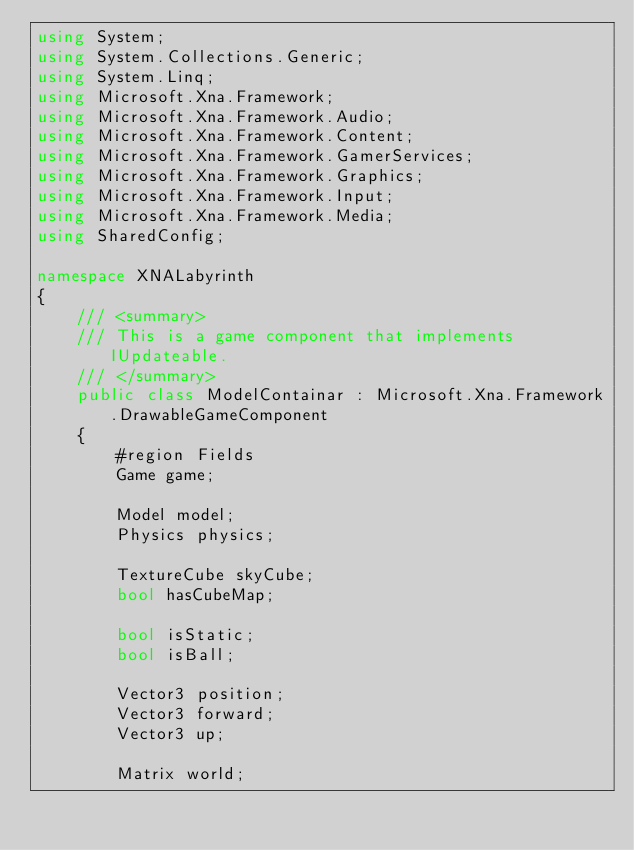<code> <loc_0><loc_0><loc_500><loc_500><_C#_>using System;
using System.Collections.Generic;
using System.Linq;
using Microsoft.Xna.Framework;
using Microsoft.Xna.Framework.Audio;
using Microsoft.Xna.Framework.Content;
using Microsoft.Xna.Framework.GamerServices;
using Microsoft.Xna.Framework.Graphics;
using Microsoft.Xna.Framework.Input;
using Microsoft.Xna.Framework.Media;
using SharedConfig;

namespace XNALabyrinth
{
    /// <summary>
    /// This is a game component that implements IUpdateable.
    /// </summary>
    public class ModelContainar : Microsoft.Xna.Framework.DrawableGameComponent
    {
        #region Fields
        Game game;
        
        Model model;
        Physics physics;

        TextureCube skyCube;
        bool hasCubeMap;

        bool isStatic;
        bool isBall;

        Vector3 position;
        Vector3 forward;
        Vector3 up;

        Matrix world;</code> 